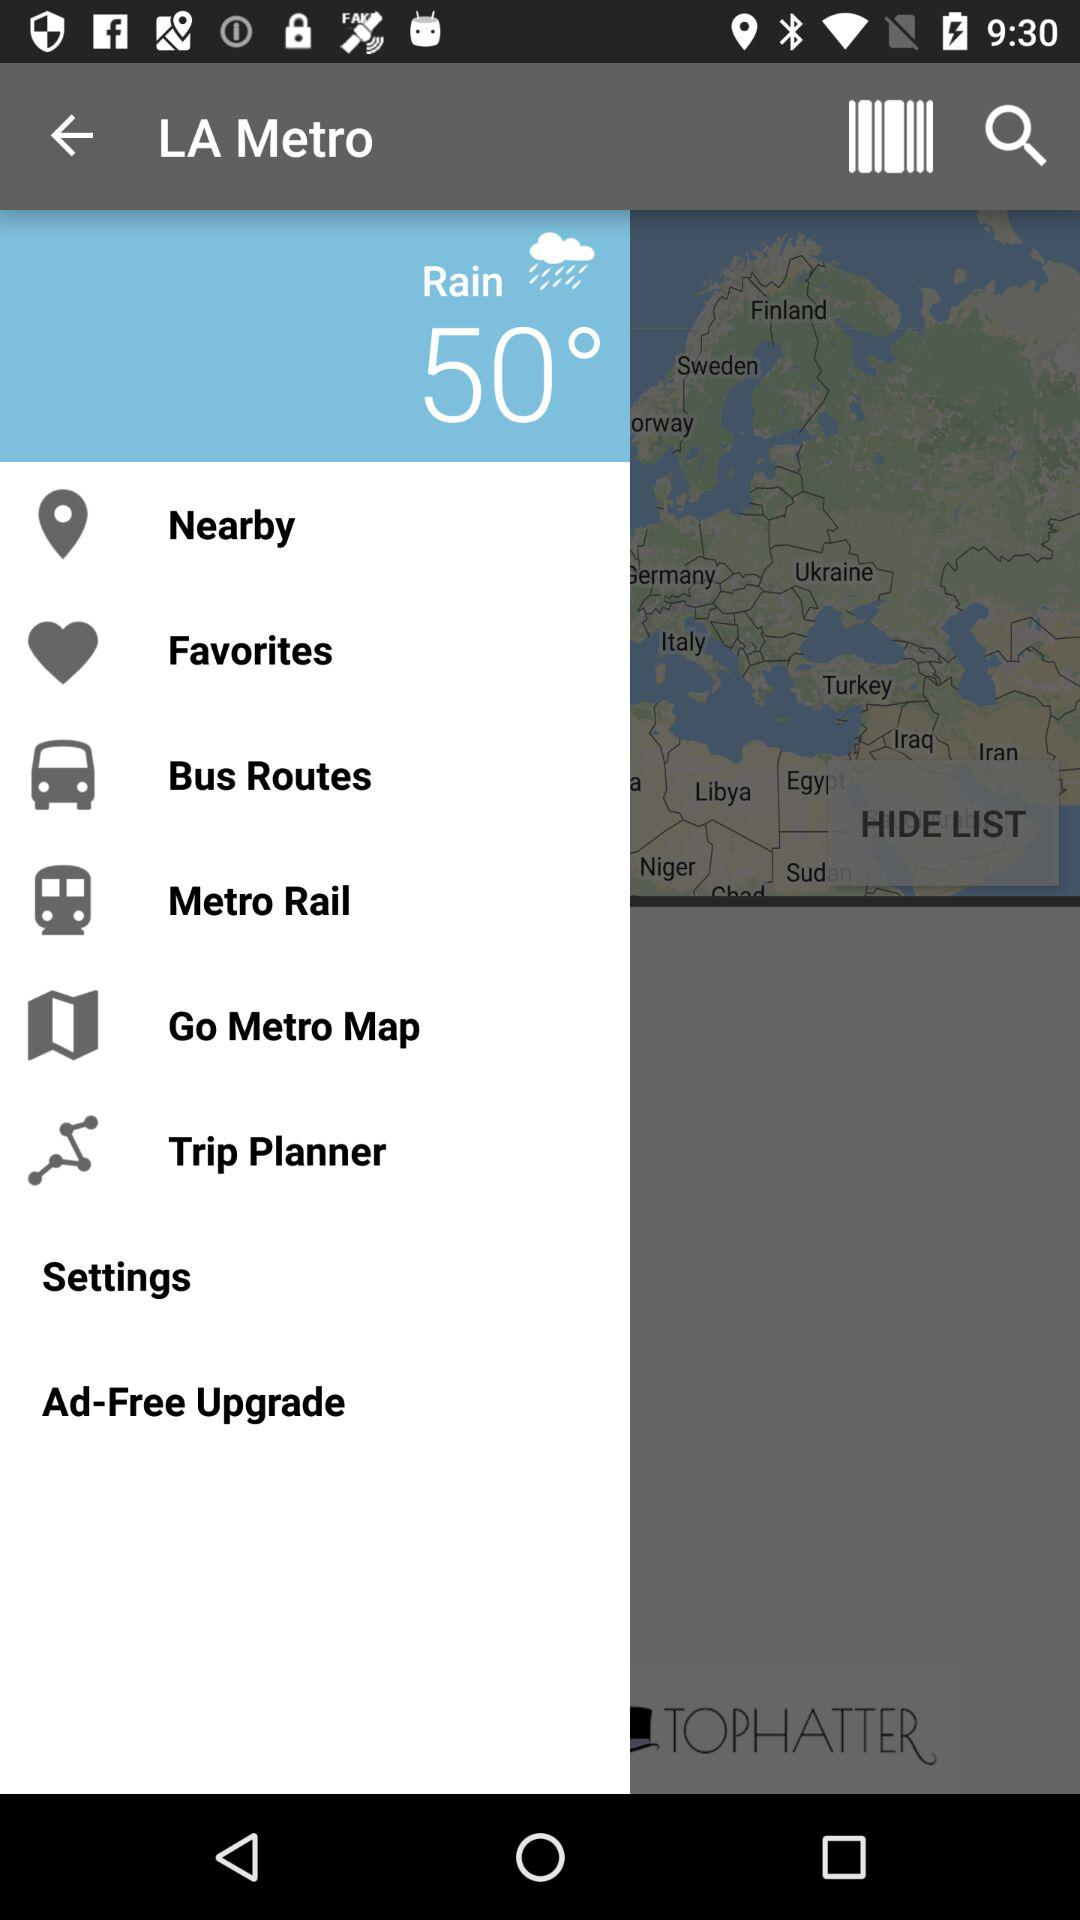How is the weather? The weather is rainy. 